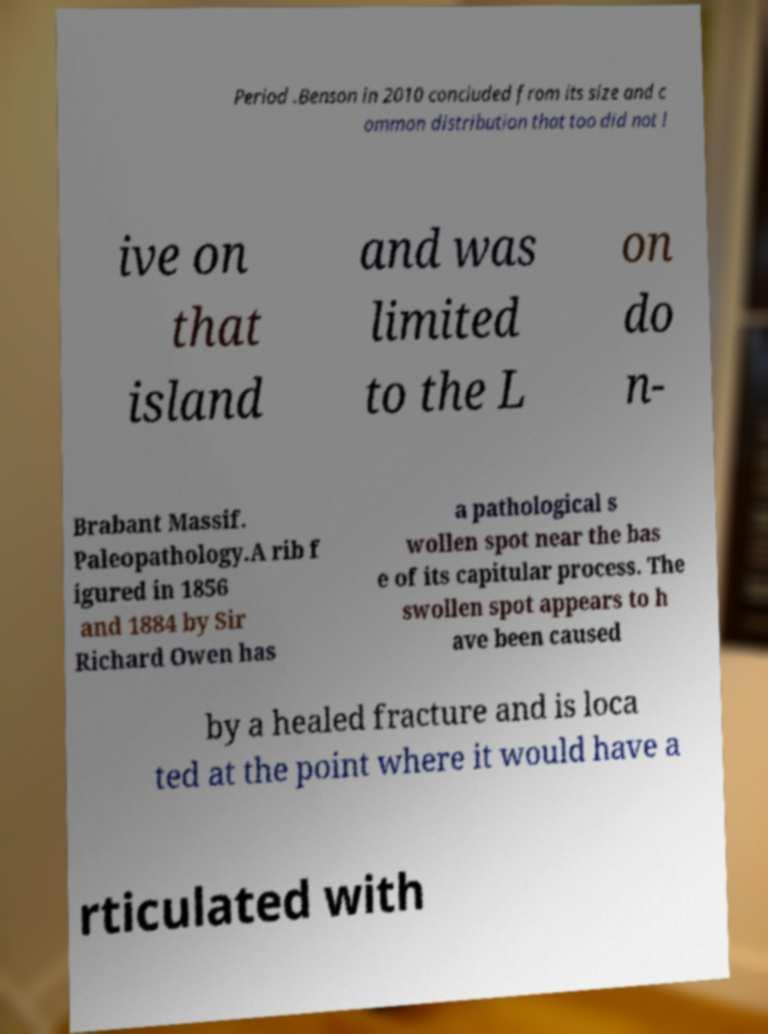Please identify and transcribe the text found in this image. Period .Benson in 2010 concluded from its size and c ommon distribution that too did not l ive on that island and was limited to the L on do n- Brabant Massif. Paleopathology.A rib f igured in 1856 and 1884 by Sir Richard Owen has a pathological s wollen spot near the bas e of its capitular process. The swollen spot appears to h ave been caused by a healed fracture and is loca ted at the point where it would have a rticulated with 